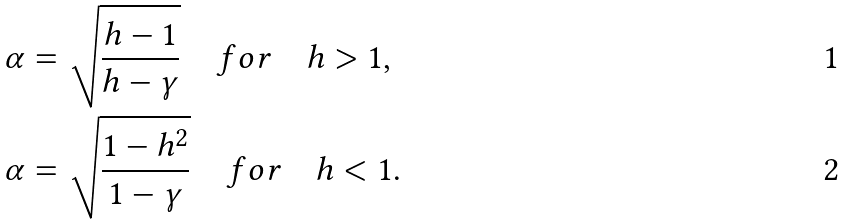<formula> <loc_0><loc_0><loc_500><loc_500>\alpha & = \sqrt { \frac { h - 1 } { h - \gamma } } \quad f o r \quad h > 1 , \\ \alpha & = \sqrt { \frac { 1 - h ^ { 2 } } { 1 - \gamma } } \quad f o r \quad h < 1 .</formula> 